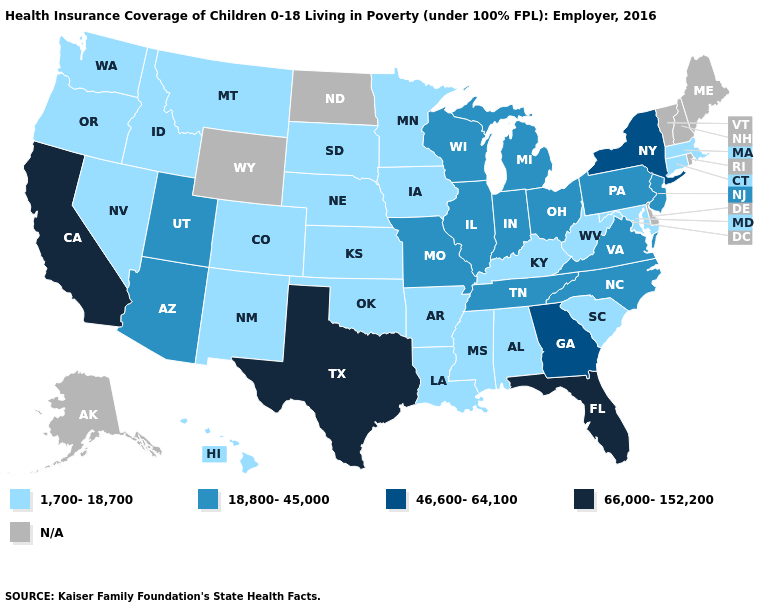Name the states that have a value in the range N/A?
Answer briefly. Alaska, Delaware, Maine, New Hampshire, North Dakota, Rhode Island, Vermont, Wyoming. Among the states that border Illinois , does Wisconsin have the lowest value?
Concise answer only. No. What is the highest value in the USA?
Write a very short answer. 66,000-152,200. Is the legend a continuous bar?
Short answer required. No. Does Connecticut have the highest value in the Northeast?
Concise answer only. No. Does Texas have the highest value in the South?
Quick response, please. Yes. What is the value of Iowa?
Write a very short answer. 1,700-18,700. Does New Mexico have the lowest value in the USA?
Concise answer only. Yes. Does Tennessee have the highest value in the USA?
Short answer required. No. Which states hav the highest value in the South?
Keep it brief. Florida, Texas. Does Florida have the highest value in the USA?
Write a very short answer. Yes. What is the value of South Carolina?
Keep it brief. 1,700-18,700. What is the value of Michigan?
Give a very brief answer. 18,800-45,000. 